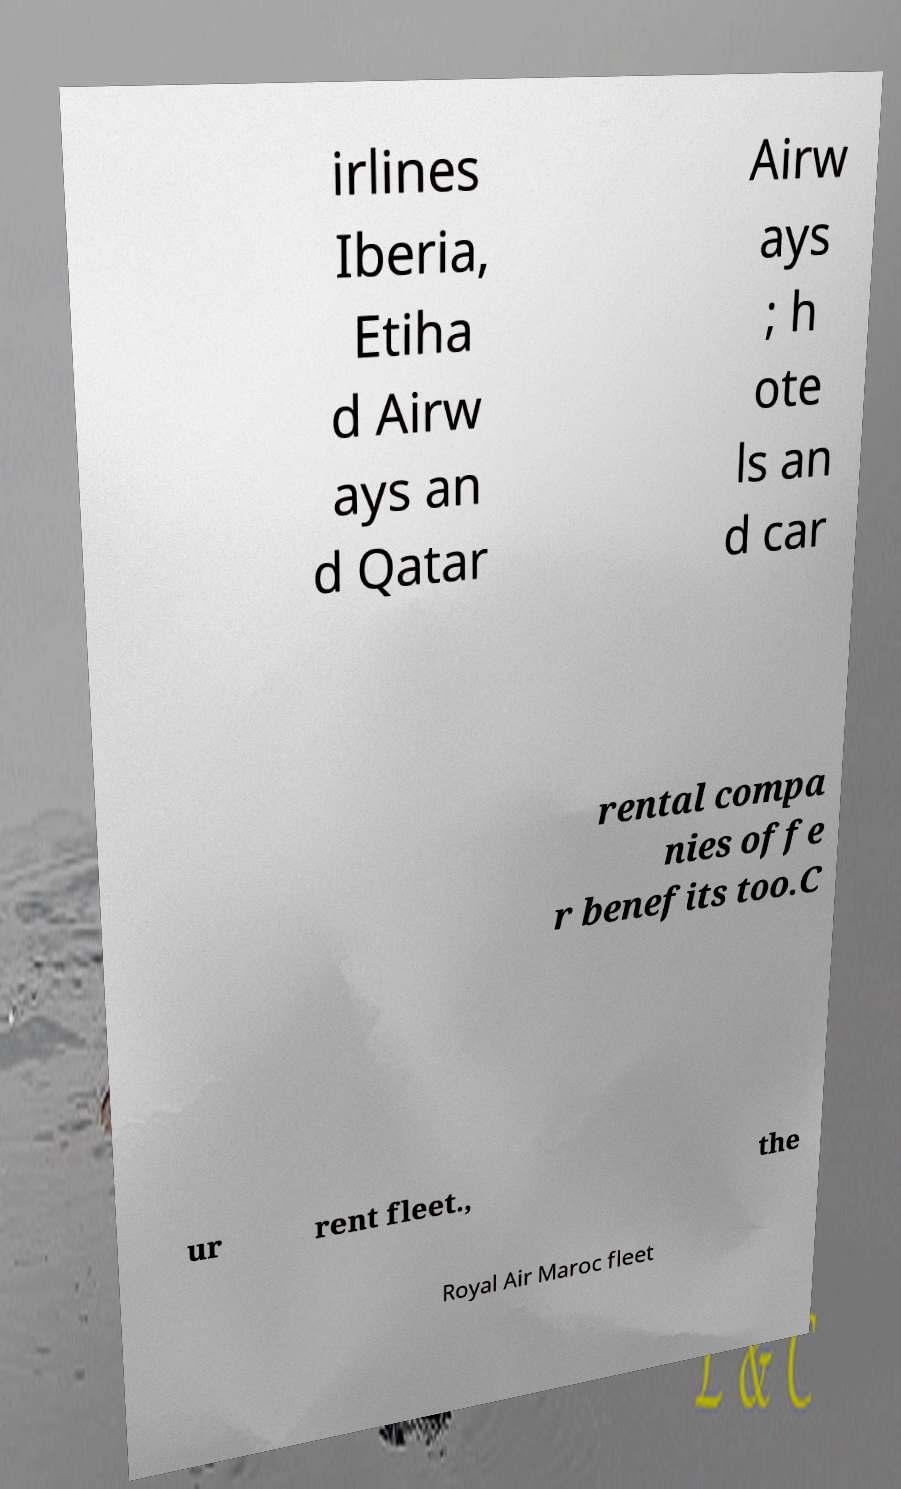Can you accurately transcribe the text from the provided image for me? irlines Iberia, Etiha d Airw ays an d Qatar Airw ays ; h ote ls an d car rental compa nies offe r benefits too.C ur rent fleet., the Royal Air Maroc fleet 